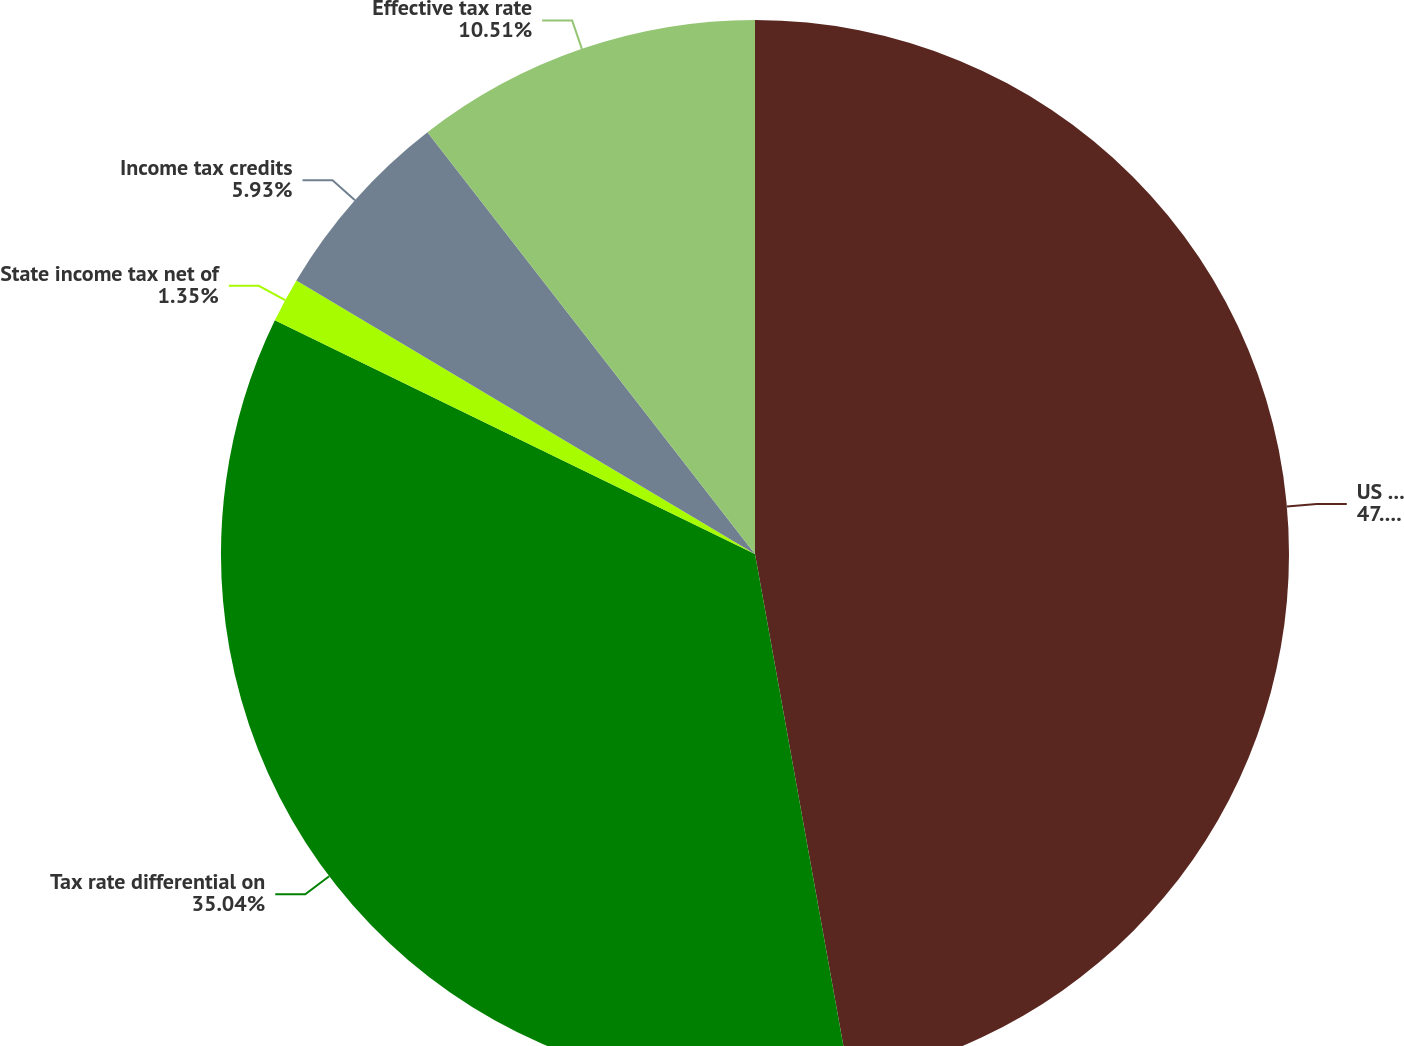Convert chart. <chart><loc_0><loc_0><loc_500><loc_500><pie_chart><fcel>US Federal statutory rate<fcel>Tax rate differential on<fcel>State income tax net of<fcel>Income tax credits<fcel>Effective tax rate<nl><fcel>47.17%<fcel>35.04%<fcel>1.35%<fcel>5.93%<fcel>10.51%<nl></chart> 